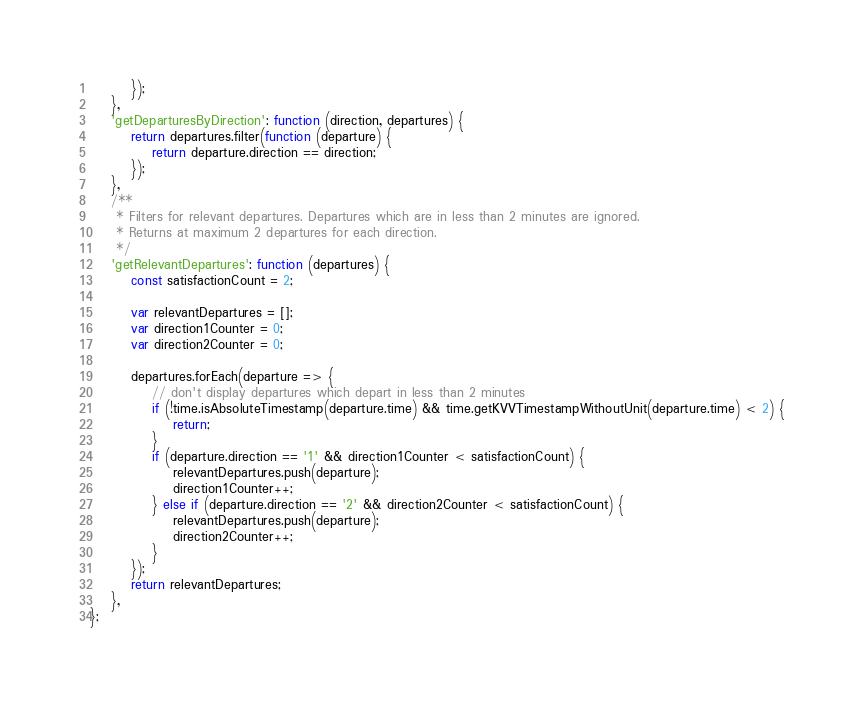Convert code to text. <code><loc_0><loc_0><loc_500><loc_500><_JavaScript_>        });
    },
    'getDeparturesByDirection': function (direction, departures) {
        return departures.filter(function (departure) {
            return departure.direction == direction;
        });
    },
    /**
     * Filters for relevant departures. Departures which are in less than 2 minutes are ignored.
     * Returns at maximum 2 departures for each direction.
     */
    'getRelevantDepartures': function (departures) {
        const satisfactionCount = 2;

        var relevantDepartures = [];
        var direction1Counter = 0;
        var direction2Counter = 0;

        departures.forEach(departure => {
            // don't display departures which depart in less than 2 minutes
            if (!time.isAbsoluteTimestamp(departure.time) && time.getKVVTimestampWithoutUnit(departure.time) < 2) {
                return;
            }
            if (departure.direction == '1' && direction1Counter < satisfactionCount) {
                relevantDepartures.push(departure);
                direction1Counter++;
            } else if (departure.direction == '2' && direction2Counter < satisfactionCount) {
                relevantDepartures.push(departure);
                direction2Counter++;
            }
        });
        return relevantDepartures;
    },
};</code> 